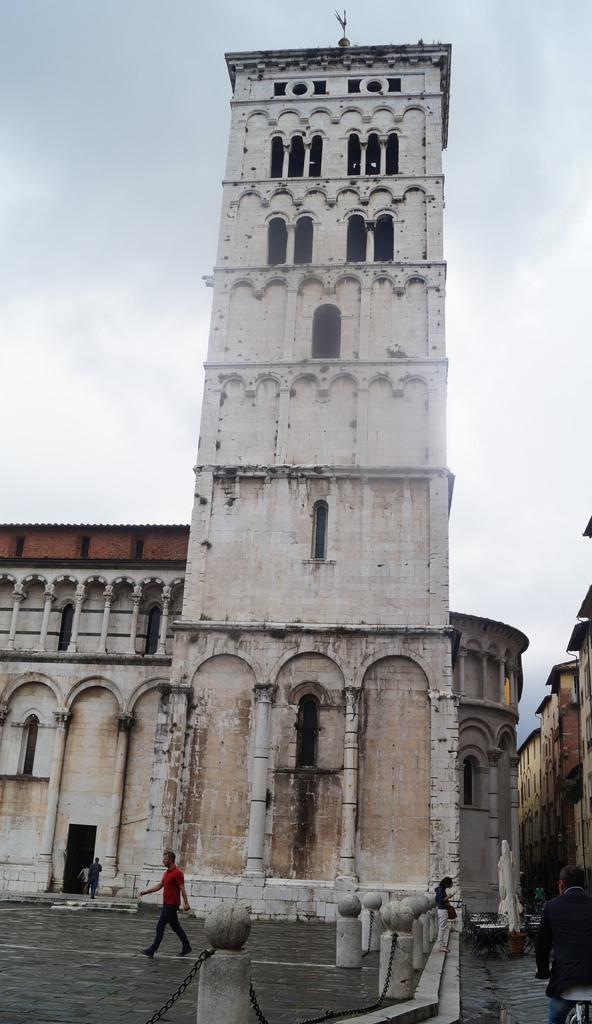What is the person in the image doing? There is a person walking in the image. What color is the shirt the person is wearing? The person is wearing a red color shirt. What can be seen in the background of the image? There is a building in the background of the image. What colors are the building in the image? The building is in white and cream color. What is visible in the sky in the image? The sky is visible in the background of the image, and it is white in color. What is the price of the record the person is holding in the image? There is no record present in the image, and therefore no price can be determined. 